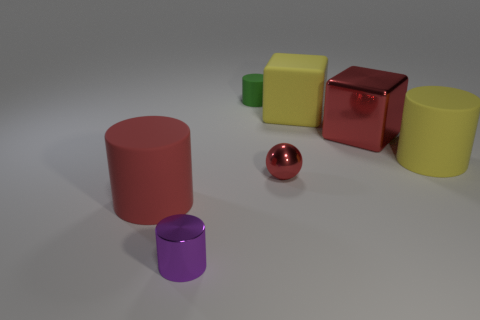Are there more blue blocks than tiny purple shiny cylinders?
Give a very brief answer. No. What color is the small shiny thing that is on the right side of the green thing?
Give a very brief answer. Red. Do the tiny purple object and the green thing have the same shape?
Give a very brief answer. Yes. There is a matte object that is to the right of the small red metallic ball and behind the large red block; what is its color?
Your response must be concise. Yellow. There is a purple metal object that is on the left side of the yellow matte cube; does it have the same size as the matte cylinder that is right of the big red block?
Provide a succinct answer. No. How many objects are either small things on the right side of the purple shiny thing or green cylinders?
Provide a succinct answer. 2. What material is the purple thing?
Your response must be concise. Metal. Do the red metal block and the red cylinder have the same size?
Your answer should be very brief. Yes. How many balls are small brown metallic objects or tiny red objects?
Keep it short and to the point. 1. What is the color of the big rubber object that is in front of the red metallic object that is in front of the big yellow matte cylinder?
Keep it short and to the point. Red. 